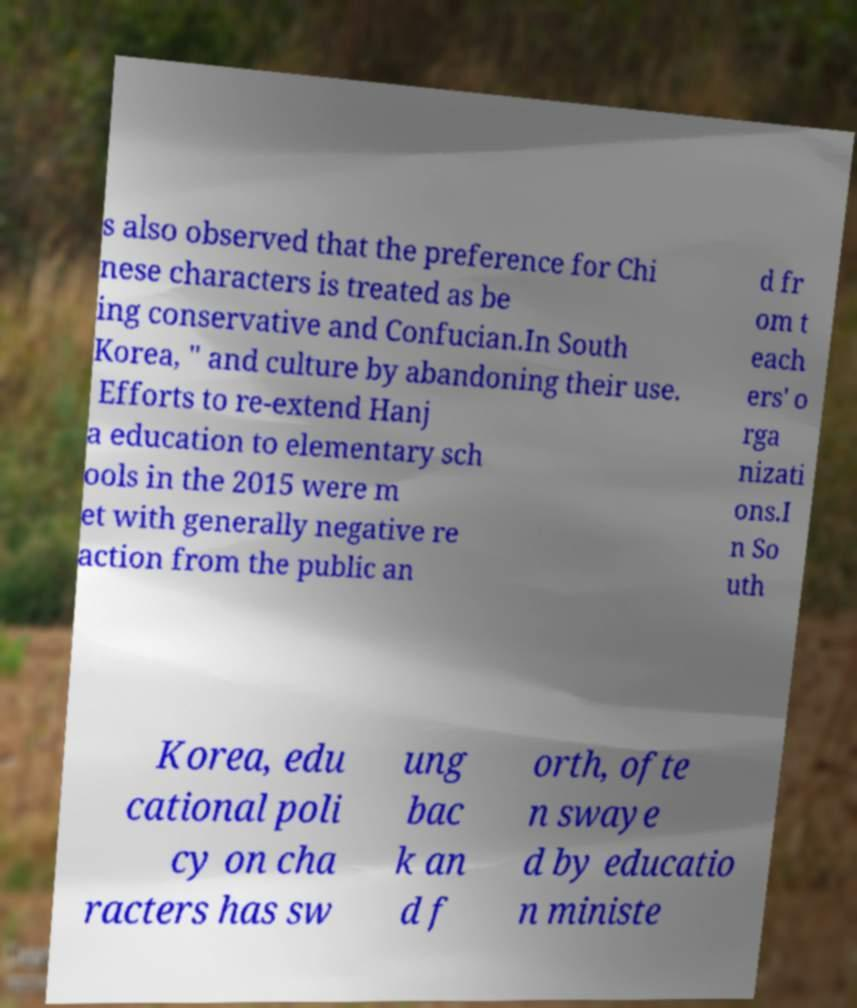There's text embedded in this image that I need extracted. Can you transcribe it verbatim? s also observed that the preference for Chi nese characters is treated as be ing conservative and Confucian.In South Korea, " and culture by abandoning their use. Efforts to re-extend Hanj a education to elementary sch ools in the 2015 were m et with generally negative re action from the public an d fr om t each ers' o rga nizati ons.I n So uth Korea, edu cational poli cy on cha racters has sw ung bac k an d f orth, ofte n swaye d by educatio n ministe 